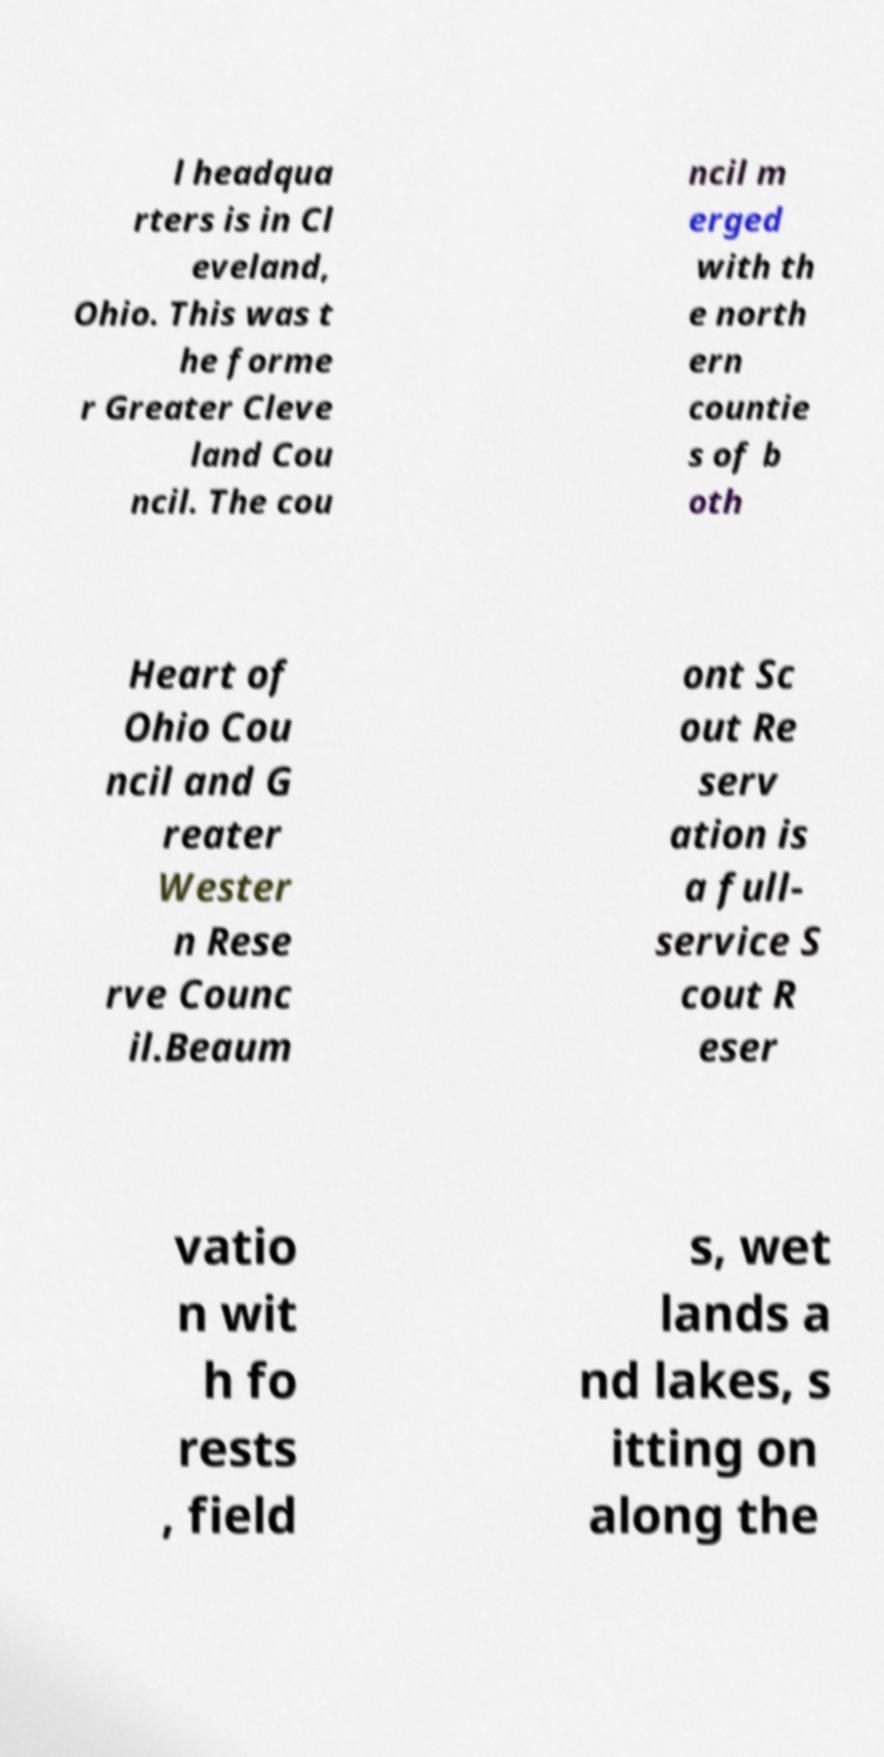For documentation purposes, I need the text within this image transcribed. Could you provide that? l headqua rters is in Cl eveland, Ohio. This was t he forme r Greater Cleve land Cou ncil. The cou ncil m erged with th e north ern countie s of b oth Heart of Ohio Cou ncil and G reater Wester n Rese rve Counc il.Beaum ont Sc out Re serv ation is a full- service S cout R eser vatio n wit h fo rests , field s, wet lands a nd lakes, s itting on along the 